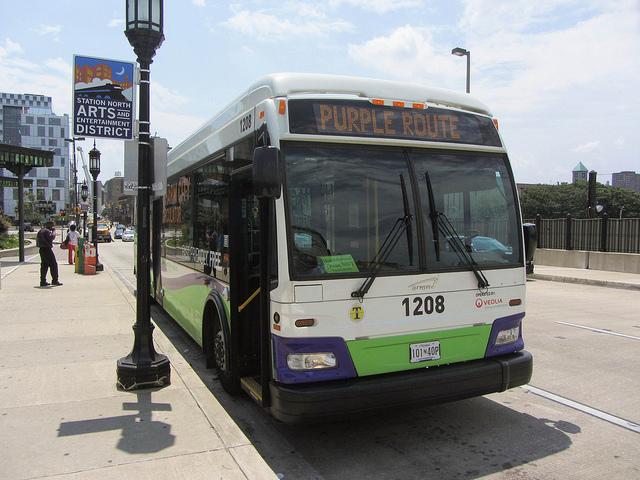What district is this bus in?
Answer briefly. Arts. What route does bus 1208 service?
Give a very brief answer. Purple route. What is standing next to the bus?
Write a very short answer. Pole. 